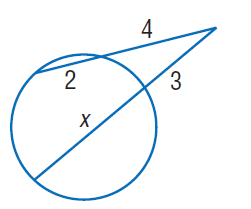Answer the mathemtical geometry problem and directly provide the correct option letter.
Question: Find x. Round to the nearest tenth if necessary. Assume that segments that appear to be tangent are tangent.
Choices: A: 2 B: 3 C: 4 D: 5 D 